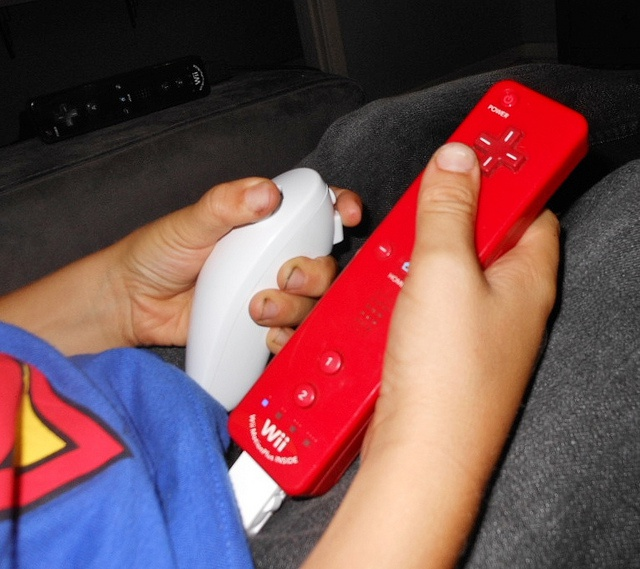Describe the objects in this image and their specific colors. I can see people in black, gray, red, and tan tones, remote in black, red, and tan tones, couch in black, maroon, tan, and salmon tones, remote in black, lightgray, darkgray, and blue tones, and remote in black and gray tones in this image. 